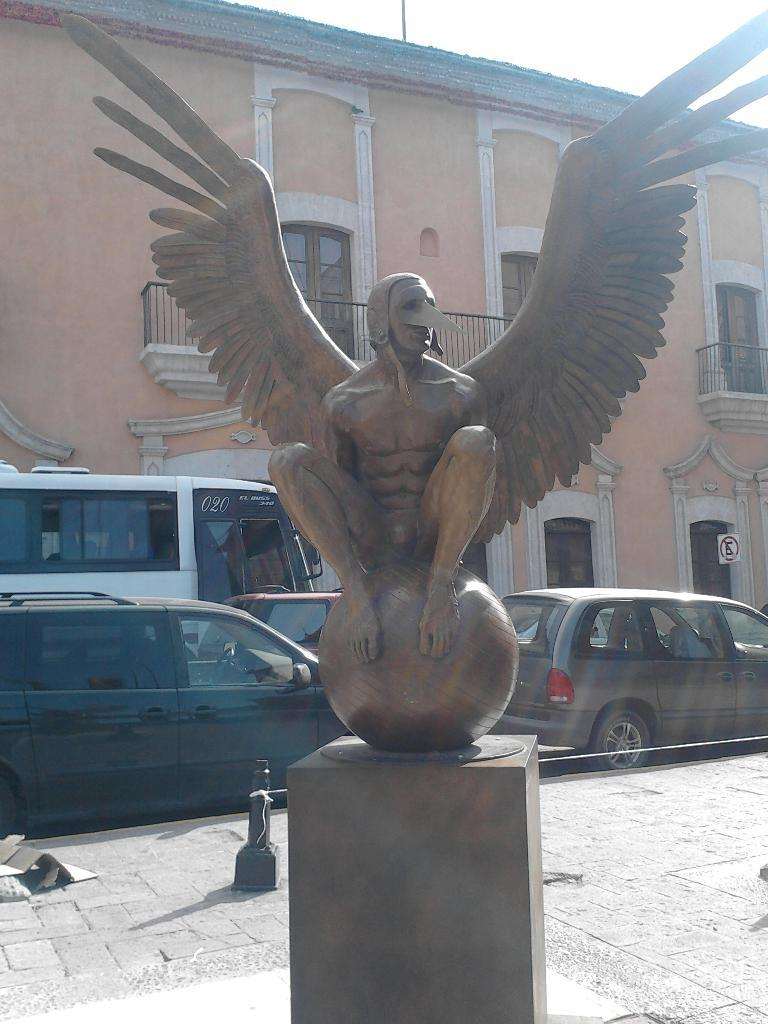What type of artwork is present in the image? There is a sculpture of a person in the image. What distinguishing feature does the sculpture have? The sculpture has wings. What else can be seen in the image besides the sculpture? There are vehicles visible in the image. What is located behind the vehicles in the image? There is a big building behind the vehicles. What type of celery is being used as a vessel in the image? There is no celery or vessel present in the image. What view can be seen from the sculpture's perspective in the image? The image does not provide a view from the sculpture's perspective, as it is a static sculpture. 